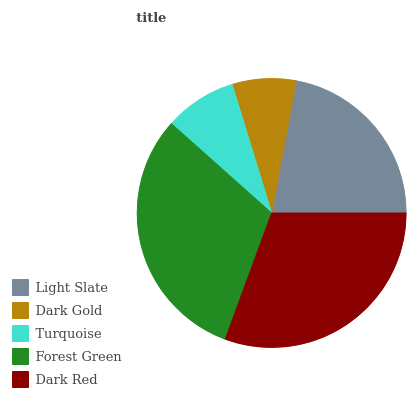Is Dark Gold the minimum?
Answer yes or no. Yes. Is Forest Green the maximum?
Answer yes or no. Yes. Is Turquoise the minimum?
Answer yes or no. No. Is Turquoise the maximum?
Answer yes or no. No. Is Turquoise greater than Dark Gold?
Answer yes or no. Yes. Is Dark Gold less than Turquoise?
Answer yes or no. Yes. Is Dark Gold greater than Turquoise?
Answer yes or no. No. Is Turquoise less than Dark Gold?
Answer yes or no. No. Is Light Slate the high median?
Answer yes or no. Yes. Is Light Slate the low median?
Answer yes or no. Yes. Is Dark Gold the high median?
Answer yes or no. No. Is Forest Green the low median?
Answer yes or no. No. 